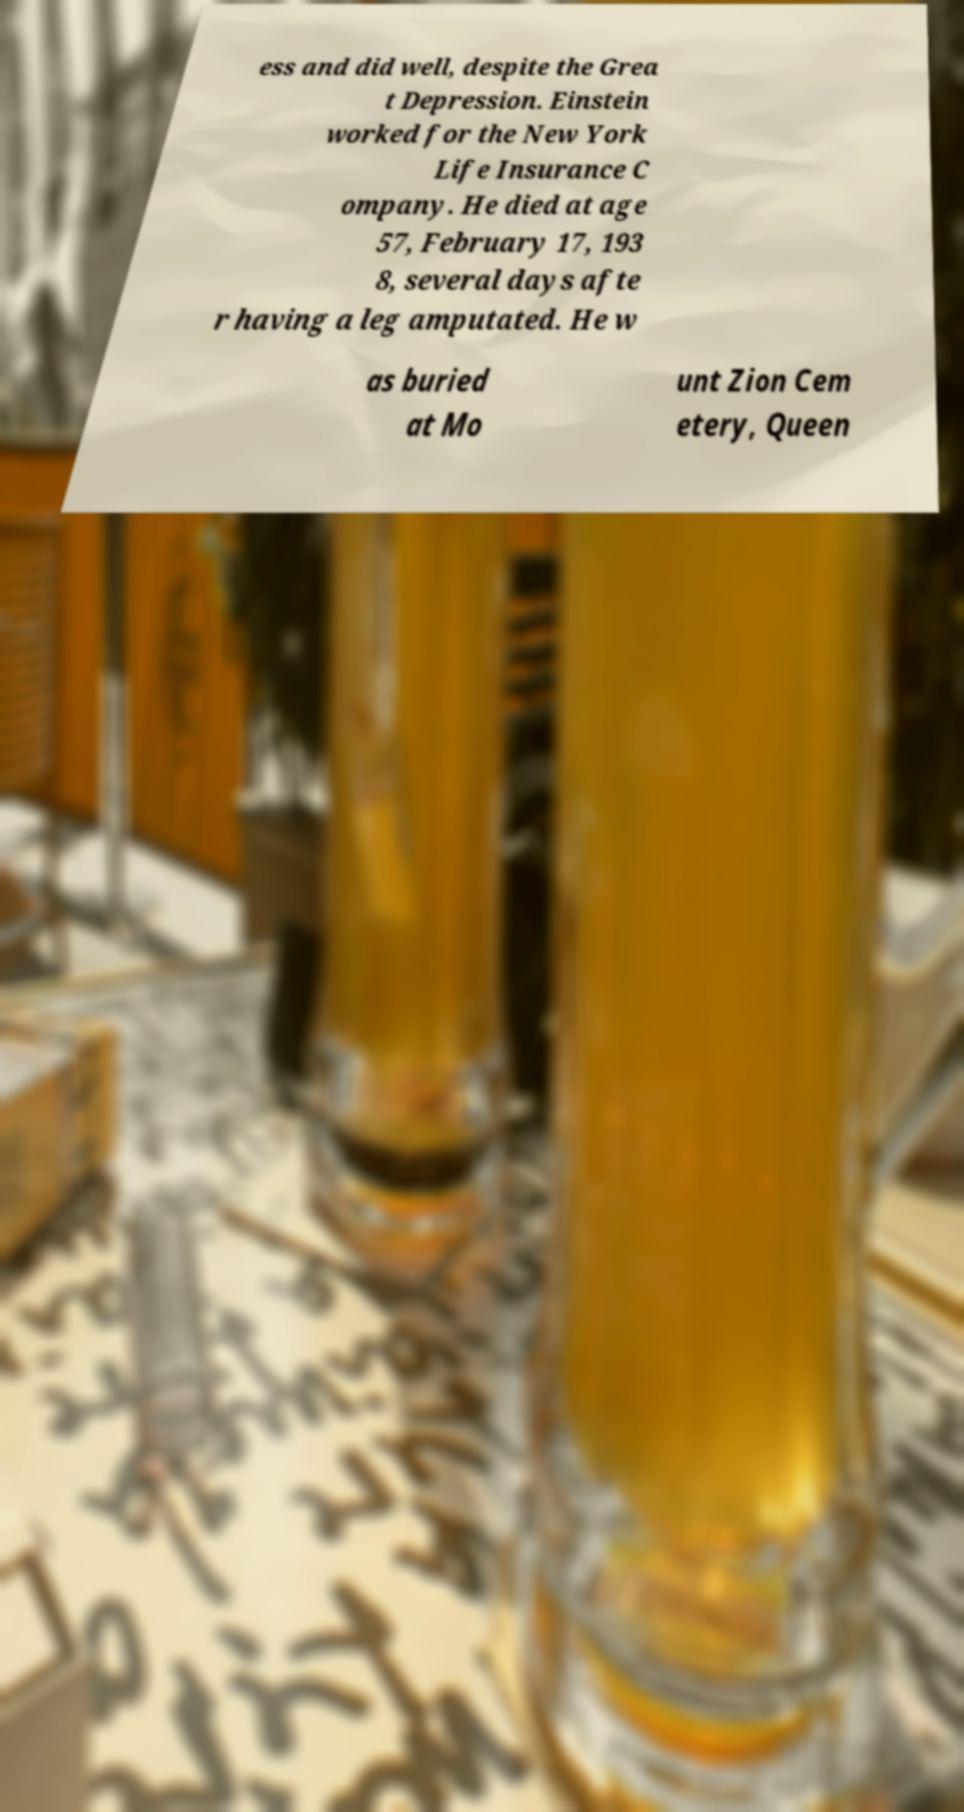Please identify and transcribe the text found in this image. ess and did well, despite the Grea t Depression. Einstein worked for the New York Life Insurance C ompany. He died at age 57, February 17, 193 8, several days afte r having a leg amputated. He w as buried at Mo unt Zion Cem etery, Queen 